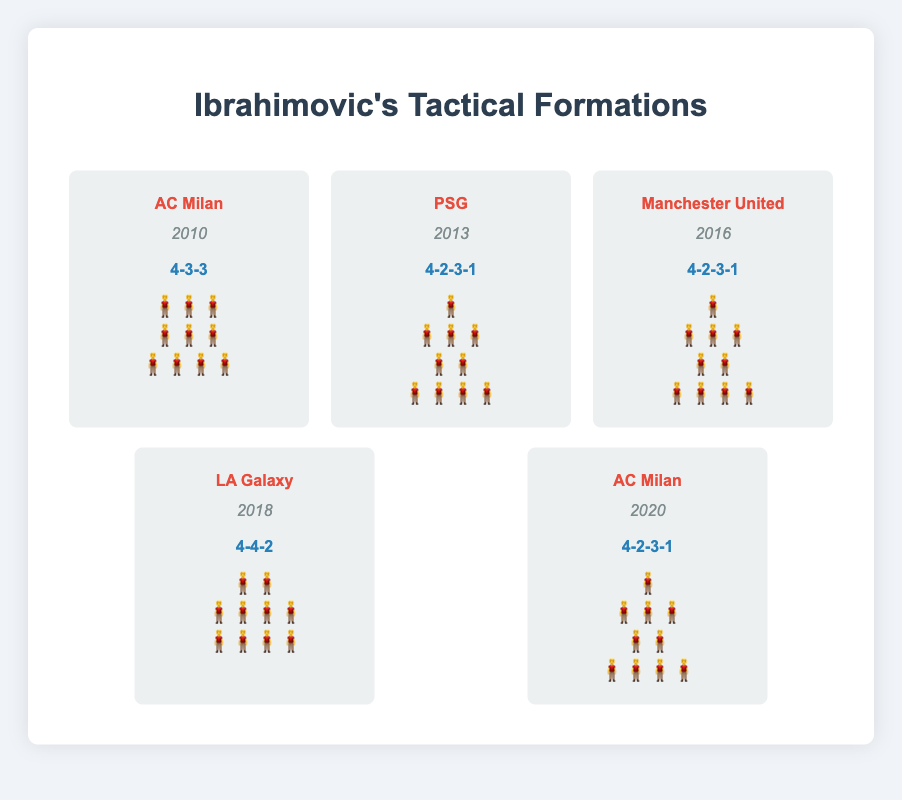What team used the 4-4-2 formation with Ibrahimovic? The figure shows the teams and formations they used. By looking at the 4-4-2 formation representation, we can see "LA Galaxy" as the team and "2018" as the year.
Answer: LA Galaxy How many times has Ibrahimovic played in a 4-2-3-1 formation? The figure lists the formations for Ibrahimovic, and we see "4-2-3-1" mentioned for three teams: PSG in 2013, Manchester United in 2016, and AC Milan in 2020.
Answer: 3 Which formation was used by AC Milan in 2010 and 2020? The figure shows "AC Milan" with "4-3-3" in 2010 and "4-2-3-1" in 2020.
Answer: 4-3-3 in 2010, 4-2-3-1 in 2020 Between PSG and LA Galaxy, which team used a more offensive formation based on the visual representation? PSG's "4-2-3-1" and LA Galaxy's "4-4-2" formations are compared. "4-2-3-1" is generally considered more offensive due to three attacking midfielders.
Answer: PSG How does the "positions" visualization differ between the 4-3-3 and 4-2-3-1 formations? The 4-3-3 formation has three rows of players: (3 players, 3 players, 4 players), while the 4-2-3-1 has four rows: (1 player, 3 players, 2 players, 4 players).
Answer: 3 rows vs. 4 rows Which formation has been most frequently used by teams with Ibrahimovic? By counting the formations in the figure: 4-2-3-1 appears three times, 4-3-3 once, and 4-4-2 once, showing 4-2-3-1 as the most frequent.
Answer: 4-2-3-1 Did Ibrahimovic's teams prefer more players in midfield or defense? Comparing the listed formations, most teams run formations (4-3-3, 4-2-3-1, 4-4-2) with more midfielders (3 in 4-3-3,3/1 in 4-2-3-1, 4 in 4-4-2) than defenders.
Answer: Midfield Has Ibrahimovic played in both 4-3-3 and 4-2-3-1 formations with AC Milan? The figure shows AC Milan using 4-3-3 in 2010 and 4-2-3-1 in 2020.
Answer: Yes Which formation appears to have the most balanced distribution of players? The 4-4-2 formation with 2 forwards, 4 midfielders, and 4 defenders looks more balanced across the lines compared to more specialized formations.
Answer: 4-4-2 